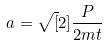Convert formula to latex. <formula><loc_0><loc_0><loc_500><loc_500>a = \sqrt { [ } 2 ] { \frac { P } { 2 m t } }</formula> 